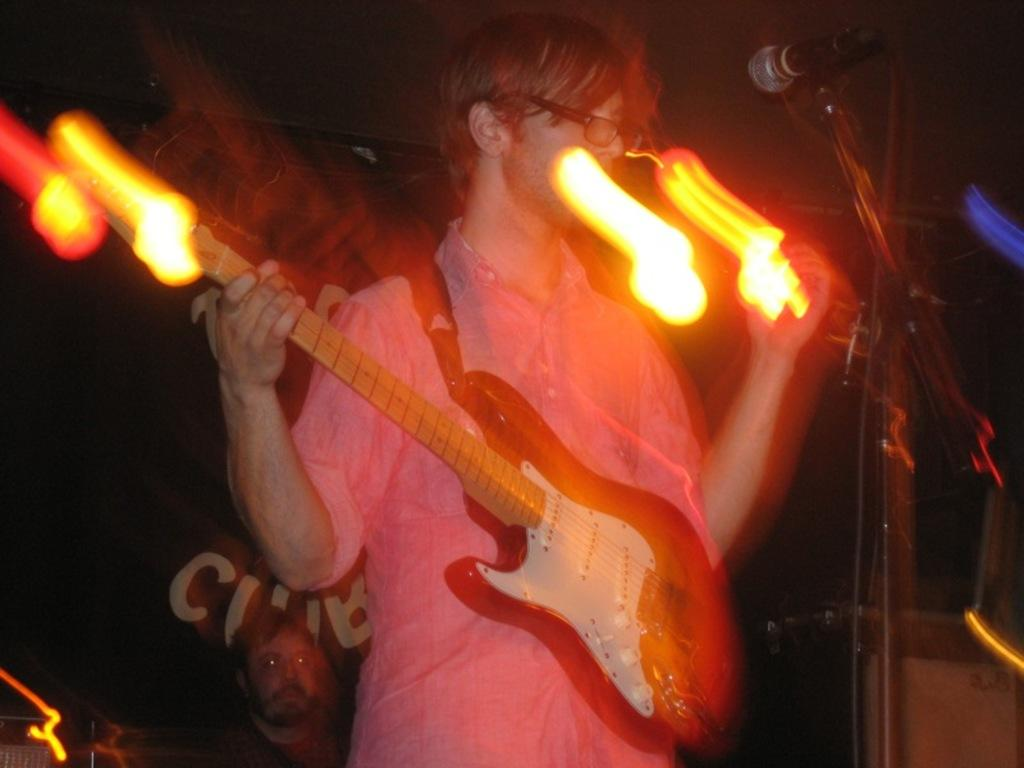What is the person in the image holding? The person is holding a guitar. Can you describe the person's appearance? The person is wearing spectacles. What object is in front of the person? There is a microphone stand in front of the person. Are there any other people visible in the image? Yes, there is another person visible at the bottom of the image. What type of pickle is the person using to play the guitar in the image? There is no pick visible in the image, and the person is not using one to play the guitar. What kind of shoes is the person wearing in the image? The image does not show the person's shoes, so we cannot determine what type they are wearing. 